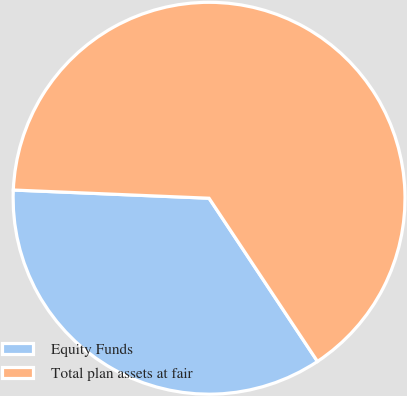Convert chart to OTSL. <chart><loc_0><loc_0><loc_500><loc_500><pie_chart><fcel>Equity Funds<fcel>Total plan assets at fair<nl><fcel>35.0%<fcel>65.0%<nl></chart> 